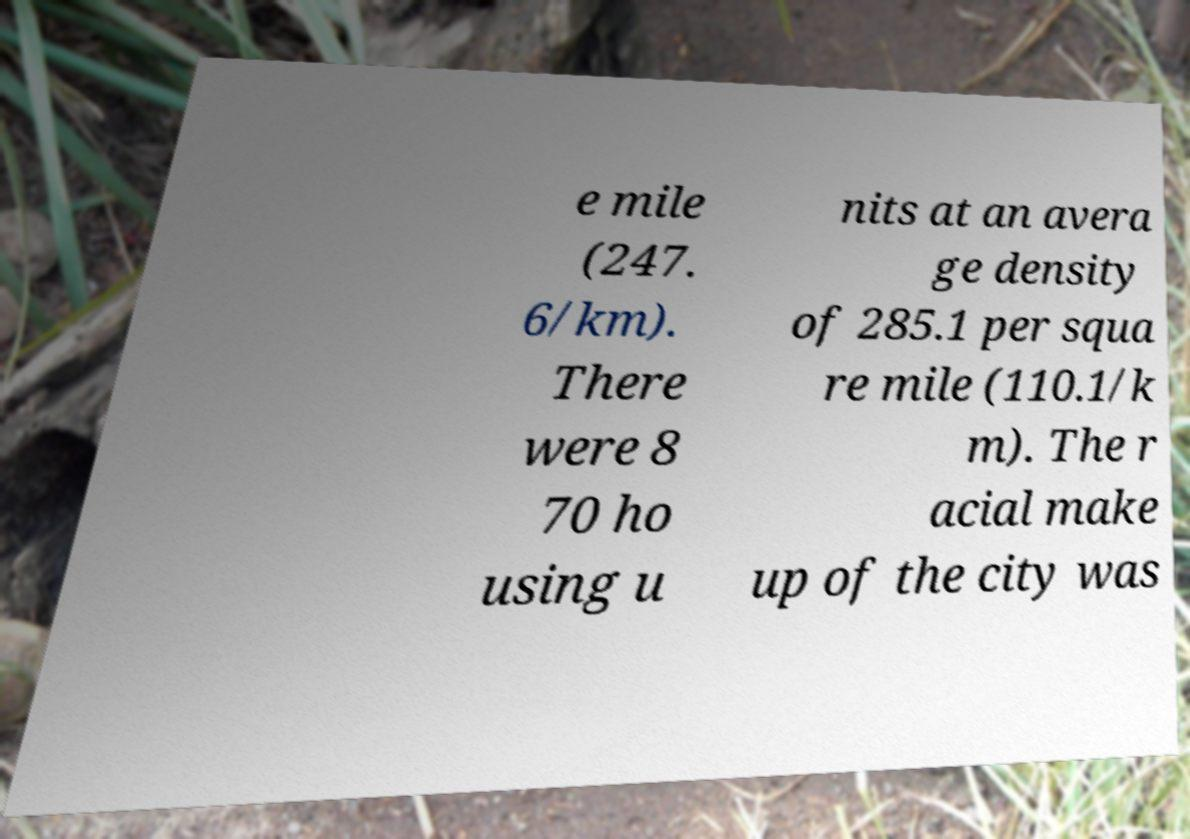I need the written content from this picture converted into text. Can you do that? e mile (247. 6/km). There were 8 70 ho using u nits at an avera ge density of 285.1 per squa re mile (110.1/k m). The r acial make up of the city was 